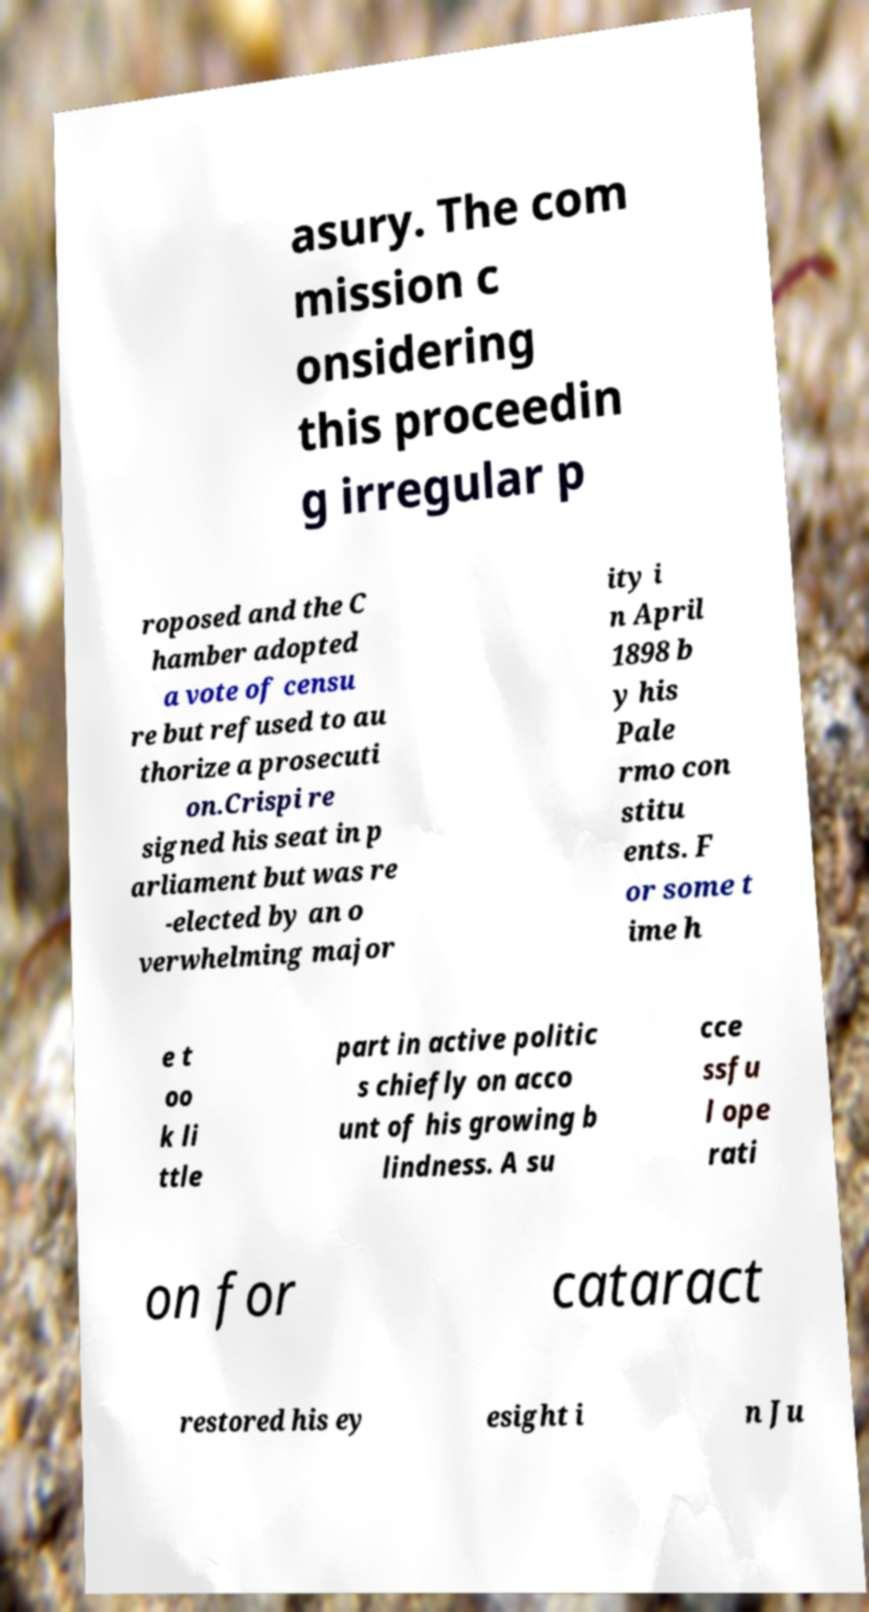What messages or text are displayed in this image? I need them in a readable, typed format. asury. The com mission c onsidering this proceedin g irregular p roposed and the C hamber adopted a vote of censu re but refused to au thorize a prosecuti on.Crispi re signed his seat in p arliament but was re -elected by an o verwhelming major ity i n April 1898 b y his Pale rmo con stitu ents. F or some t ime h e t oo k li ttle part in active politic s chiefly on acco unt of his growing b lindness. A su cce ssfu l ope rati on for cataract restored his ey esight i n Ju 